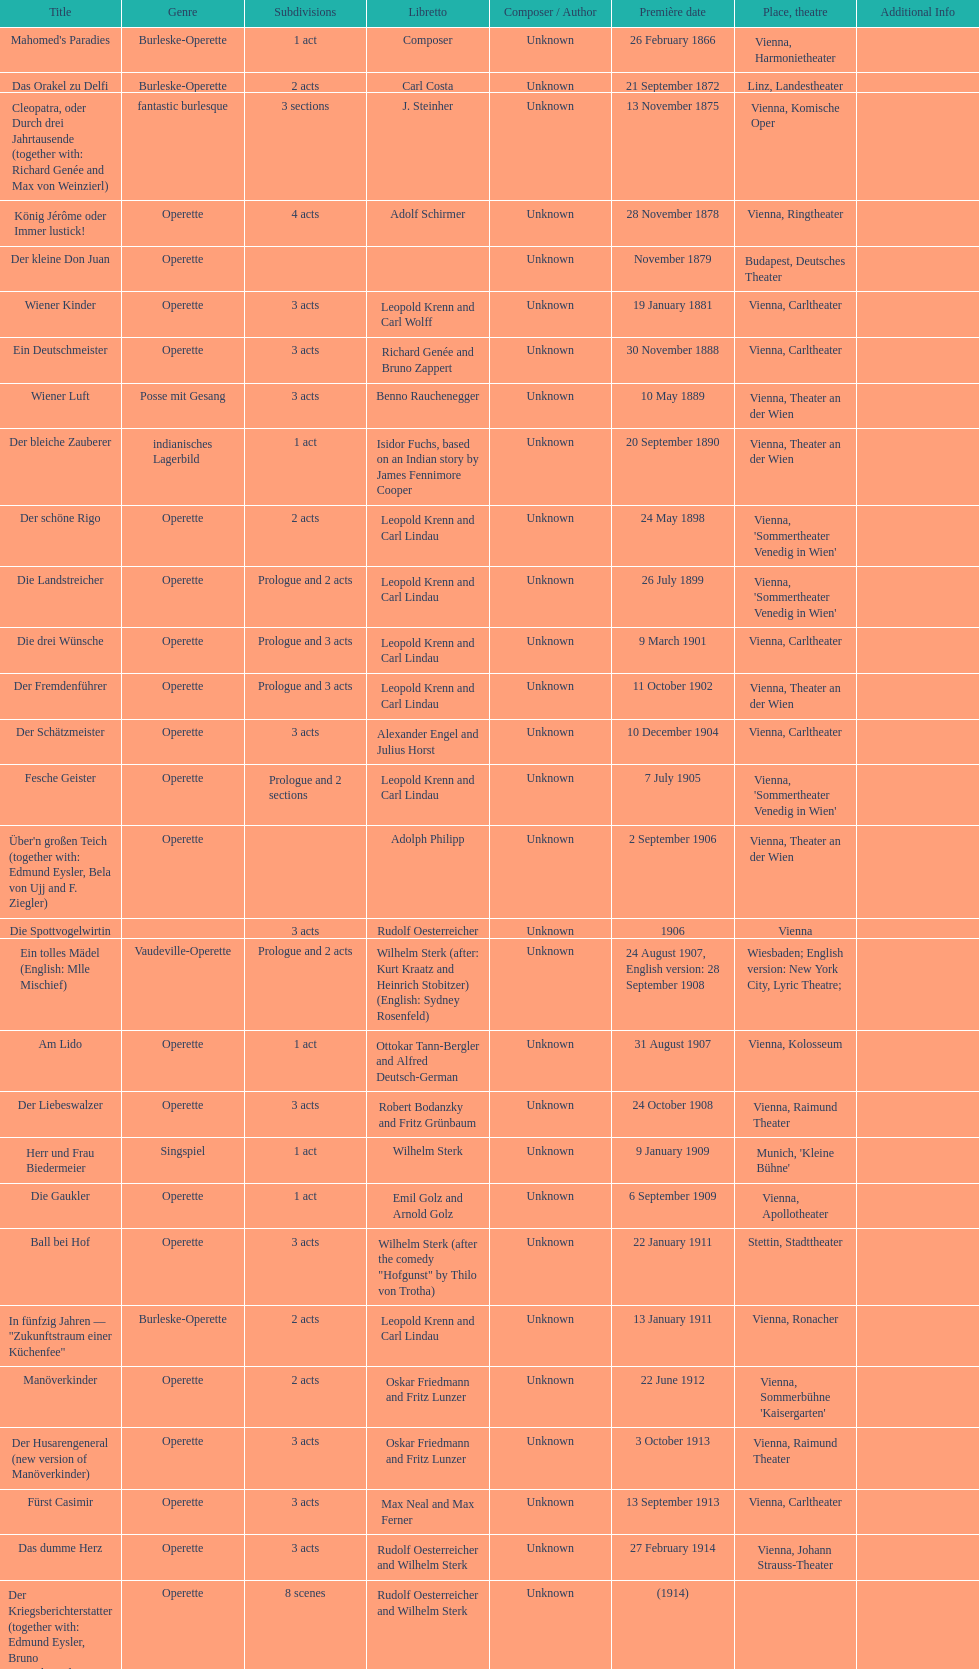All the dates are no later than what year? 1958. 